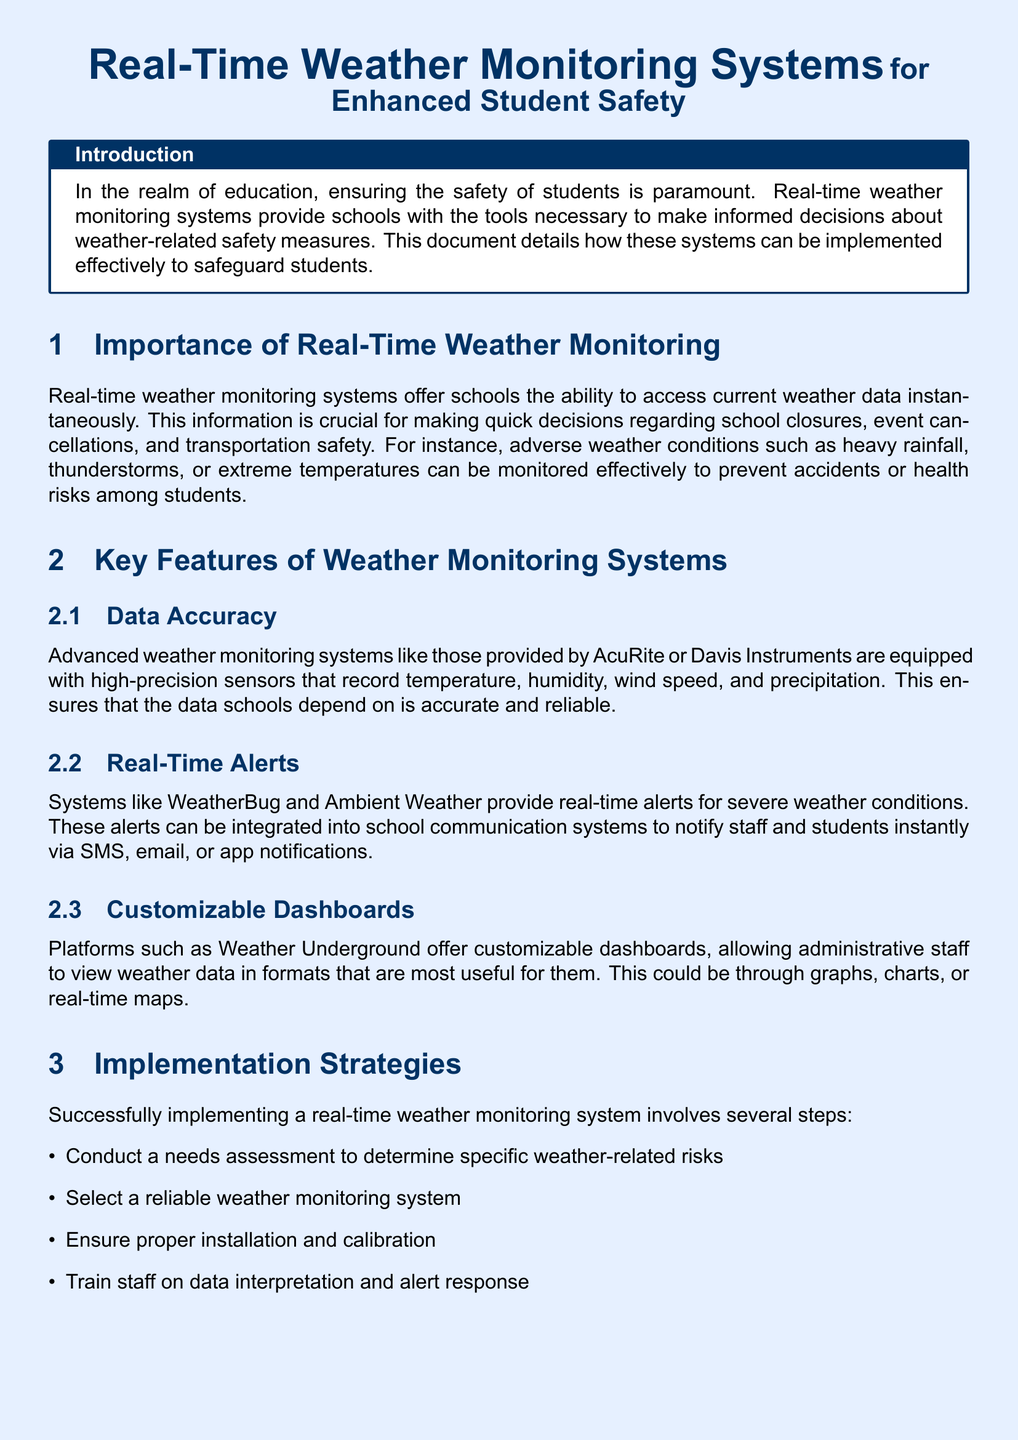What is the title of the document? The title of the document is explicitly mentioned at the top as "Real-Time Weather Monitoring Systems for Enhanced Student Safety."
Answer: Real-Time Weather Monitoring Systems for Enhanced Student Safety What is the primary focus of real-time weather monitoring systems in schools? The document states that the primary focus is on ensuring the safety of students by providing informed decisions on weather-related safety measures.
Answer: Student safety Which two weather monitoring systems are mentioned for data accuracy? The document lists AcuRite and Davis Instruments as advanced weather monitoring systems equipped with high-precision sensors.
Answer: AcuRite, Davis Instruments What key feature do real-time alerts offer? Real-time alerts provide instant notifications for severe weather conditions, allowing schools to respond quickly.
Answer: Instant notifications How many implementation strategies are listed in the document? The document outlines four implementation strategies for successfully implementing a weather monitoring system.
Answer: Four What case study is referenced in the document? The case study mentioned in the document is about Lincoln High School in Kansas City.
Answer: Lincoln High School What improvement did Lincoln High School note after implementation? The administration noted a significant improvement in decision-making regarding weather-related cancellations and delays.
Answer: Significant improvement What is the conclusion of the document regarding real-time weather monitoring systems? The conclusion emphasizes that real-time weather monitoring systems enhance student safety by allowing schools to manage weather-related risks proactively.
Answer: Enhance student safety 